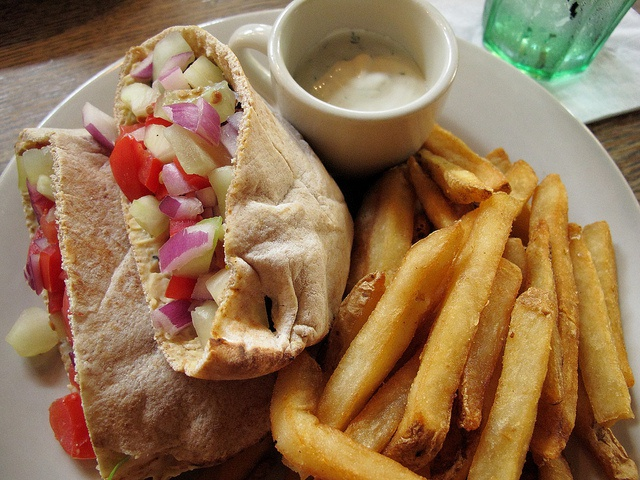Describe the objects in this image and their specific colors. I can see sandwich in black, tan, and brown tones, sandwich in black, maroon, gray, and tan tones, cup in black, maroon, olive, gray, and lightgray tones, and cup in black, green, turquoise, and darkgray tones in this image. 